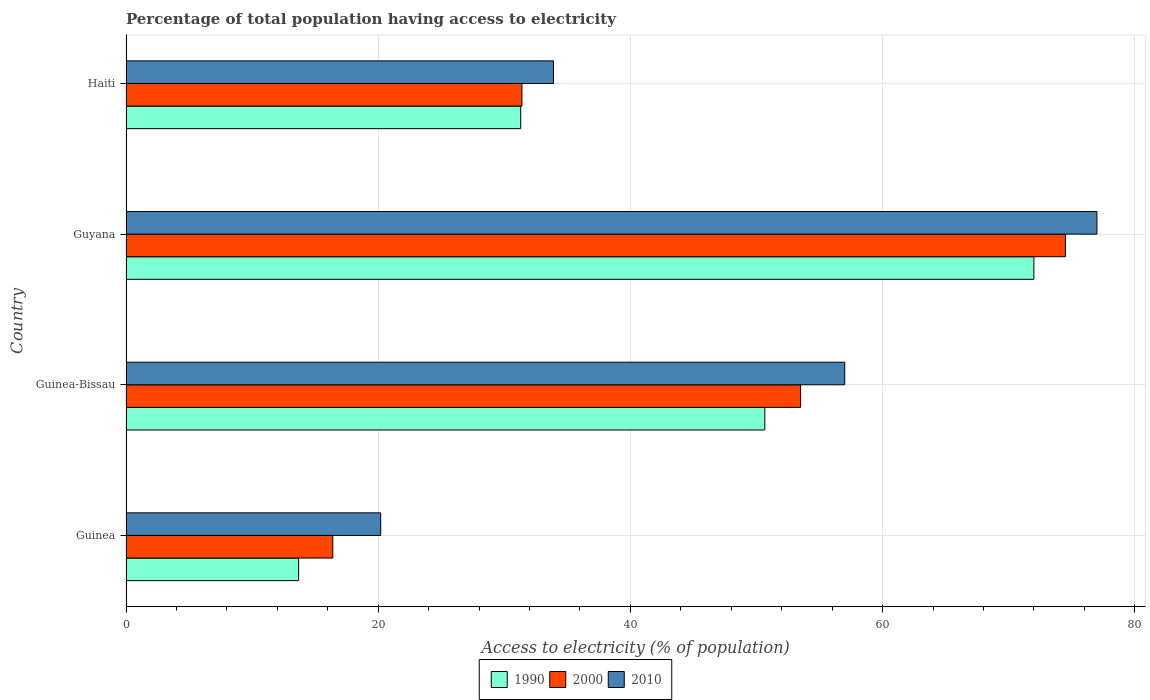How many different coloured bars are there?
Your response must be concise. 3. How many groups of bars are there?
Ensure brevity in your answer.  4. How many bars are there on the 2nd tick from the top?
Make the answer very short. 3. How many bars are there on the 1st tick from the bottom?
Offer a very short reply. 3. What is the label of the 4th group of bars from the top?
Your response must be concise. Guinea. What is the percentage of population that have access to electricity in 2000 in Guinea-Bissau?
Your answer should be very brief. 53.5. Across all countries, what is the maximum percentage of population that have access to electricity in 2000?
Your response must be concise. 74.5. Across all countries, what is the minimum percentage of population that have access to electricity in 1990?
Offer a terse response. 13.69. In which country was the percentage of population that have access to electricity in 1990 maximum?
Provide a short and direct response. Guyana. In which country was the percentage of population that have access to electricity in 2010 minimum?
Make the answer very short. Guinea. What is the total percentage of population that have access to electricity in 1990 in the graph?
Offer a very short reply. 167.65. What is the difference between the percentage of population that have access to electricity in 2000 in Guinea-Bissau and that in Haiti?
Offer a very short reply. 22.1. What is the average percentage of population that have access to electricity in 2010 per country?
Offer a terse response. 47.02. What is the difference between the percentage of population that have access to electricity in 2010 and percentage of population that have access to electricity in 1990 in Guinea?
Keep it short and to the point. 6.51. What is the ratio of the percentage of population that have access to electricity in 2010 in Guinea to that in Haiti?
Keep it short and to the point. 0.6. Is the percentage of population that have access to electricity in 2000 in Guinea less than that in Guinea-Bissau?
Ensure brevity in your answer.  Yes. What is the difference between the highest and the lowest percentage of population that have access to electricity in 2000?
Give a very brief answer. 58.1. Is the sum of the percentage of population that have access to electricity in 2010 in Guinea-Bissau and Guyana greater than the maximum percentage of population that have access to electricity in 2000 across all countries?
Offer a very short reply. Yes. What does the 1st bar from the top in Guinea represents?
Give a very brief answer. 2010. How many bars are there?
Provide a succinct answer. 12. Are all the bars in the graph horizontal?
Give a very brief answer. Yes. What is the difference between two consecutive major ticks on the X-axis?
Offer a terse response. 20. Are the values on the major ticks of X-axis written in scientific E-notation?
Your answer should be very brief. No. Does the graph contain grids?
Your response must be concise. Yes. How are the legend labels stacked?
Provide a short and direct response. Horizontal. What is the title of the graph?
Provide a succinct answer. Percentage of total population having access to electricity. Does "2006" appear as one of the legend labels in the graph?
Ensure brevity in your answer.  No. What is the label or title of the X-axis?
Your answer should be compact. Access to electricity (% of population). What is the label or title of the Y-axis?
Offer a terse response. Country. What is the Access to electricity (% of population) of 1990 in Guinea?
Your answer should be very brief. 13.69. What is the Access to electricity (% of population) in 2010 in Guinea?
Provide a short and direct response. 20.2. What is the Access to electricity (% of population) in 1990 in Guinea-Bissau?
Offer a very short reply. 50.66. What is the Access to electricity (% of population) in 2000 in Guinea-Bissau?
Make the answer very short. 53.5. What is the Access to electricity (% of population) of 2010 in Guinea-Bissau?
Provide a succinct answer. 57. What is the Access to electricity (% of population) of 2000 in Guyana?
Offer a terse response. 74.5. What is the Access to electricity (% of population) of 2010 in Guyana?
Ensure brevity in your answer.  77. What is the Access to electricity (% of population) of 1990 in Haiti?
Give a very brief answer. 31.3. What is the Access to electricity (% of population) of 2000 in Haiti?
Your answer should be very brief. 31.4. What is the Access to electricity (% of population) of 2010 in Haiti?
Keep it short and to the point. 33.9. Across all countries, what is the maximum Access to electricity (% of population) in 2000?
Provide a short and direct response. 74.5. Across all countries, what is the maximum Access to electricity (% of population) in 2010?
Ensure brevity in your answer.  77. Across all countries, what is the minimum Access to electricity (% of population) in 1990?
Ensure brevity in your answer.  13.69. Across all countries, what is the minimum Access to electricity (% of population) of 2000?
Make the answer very short. 16.4. Across all countries, what is the minimum Access to electricity (% of population) in 2010?
Your response must be concise. 20.2. What is the total Access to electricity (% of population) in 1990 in the graph?
Keep it short and to the point. 167.65. What is the total Access to electricity (% of population) in 2000 in the graph?
Your answer should be compact. 175.8. What is the total Access to electricity (% of population) in 2010 in the graph?
Give a very brief answer. 188.1. What is the difference between the Access to electricity (% of population) of 1990 in Guinea and that in Guinea-Bissau?
Offer a very short reply. -36.97. What is the difference between the Access to electricity (% of population) in 2000 in Guinea and that in Guinea-Bissau?
Ensure brevity in your answer.  -37.1. What is the difference between the Access to electricity (% of population) in 2010 in Guinea and that in Guinea-Bissau?
Provide a succinct answer. -36.8. What is the difference between the Access to electricity (% of population) of 1990 in Guinea and that in Guyana?
Offer a terse response. -58.31. What is the difference between the Access to electricity (% of population) of 2000 in Guinea and that in Guyana?
Keep it short and to the point. -58.1. What is the difference between the Access to electricity (% of population) in 2010 in Guinea and that in Guyana?
Your answer should be very brief. -56.8. What is the difference between the Access to electricity (% of population) in 1990 in Guinea and that in Haiti?
Keep it short and to the point. -17.61. What is the difference between the Access to electricity (% of population) in 2000 in Guinea and that in Haiti?
Offer a very short reply. -15. What is the difference between the Access to electricity (% of population) in 2010 in Guinea and that in Haiti?
Ensure brevity in your answer.  -13.7. What is the difference between the Access to electricity (% of population) in 1990 in Guinea-Bissau and that in Guyana?
Ensure brevity in your answer.  -21.34. What is the difference between the Access to electricity (% of population) in 1990 in Guinea-Bissau and that in Haiti?
Keep it short and to the point. 19.36. What is the difference between the Access to electricity (% of population) of 2000 in Guinea-Bissau and that in Haiti?
Your answer should be compact. 22.1. What is the difference between the Access to electricity (% of population) in 2010 in Guinea-Bissau and that in Haiti?
Your answer should be very brief. 23.1. What is the difference between the Access to electricity (% of population) in 1990 in Guyana and that in Haiti?
Your response must be concise. 40.7. What is the difference between the Access to electricity (% of population) in 2000 in Guyana and that in Haiti?
Your answer should be compact. 43.1. What is the difference between the Access to electricity (% of population) of 2010 in Guyana and that in Haiti?
Give a very brief answer. 43.1. What is the difference between the Access to electricity (% of population) of 1990 in Guinea and the Access to electricity (% of population) of 2000 in Guinea-Bissau?
Provide a short and direct response. -39.81. What is the difference between the Access to electricity (% of population) of 1990 in Guinea and the Access to electricity (% of population) of 2010 in Guinea-Bissau?
Ensure brevity in your answer.  -43.31. What is the difference between the Access to electricity (% of population) in 2000 in Guinea and the Access to electricity (% of population) in 2010 in Guinea-Bissau?
Provide a succinct answer. -40.6. What is the difference between the Access to electricity (% of population) of 1990 in Guinea and the Access to electricity (% of population) of 2000 in Guyana?
Your answer should be compact. -60.81. What is the difference between the Access to electricity (% of population) in 1990 in Guinea and the Access to electricity (% of population) in 2010 in Guyana?
Your response must be concise. -63.31. What is the difference between the Access to electricity (% of population) in 2000 in Guinea and the Access to electricity (% of population) in 2010 in Guyana?
Provide a short and direct response. -60.6. What is the difference between the Access to electricity (% of population) of 1990 in Guinea and the Access to electricity (% of population) of 2000 in Haiti?
Provide a short and direct response. -17.71. What is the difference between the Access to electricity (% of population) of 1990 in Guinea and the Access to electricity (% of population) of 2010 in Haiti?
Give a very brief answer. -20.21. What is the difference between the Access to electricity (% of population) in 2000 in Guinea and the Access to electricity (% of population) in 2010 in Haiti?
Provide a succinct answer. -17.5. What is the difference between the Access to electricity (% of population) in 1990 in Guinea-Bissau and the Access to electricity (% of population) in 2000 in Guyana?
Your answer should be very brief. -23.84. What is the difference between the Access to electricity (% of population) of 1990 in Guinea-Bissau and the Access to electricity (% of population) of 2010 in Guyana?
Make the answer very short. -26.34. What is the difference between the Access to electricity (% of population) of 2000 in Guinea-Bissau and the Access to electricity (% of population) of 2010 in Guyana?
Make the answer very short. -23.5. What is the difference between the Access to electricity (% of population) of 1990 in Guinea-Bissau and the Access to electricity (% of population) of 2000 in Haiti?
Ensure brevity in your answer.  19.26. What is the difference between the Access to electricity (% of population) in 1990 in Guinea-Bissau and the Access to electricity (% of population) in 2010 in Haiti?
Make the answer very short. 16.76. What is the difference between the Access to electricity (% of population) of 2000 in Guinea-Bissau and the Access to electricity (% of population) of 2010 in Haiti?
Your response must be concise. 19.6. What is the difference between the Access to electricity (% of population) in 1990 in Guyana and the Access to electricity (% of population) in 2000 in Haiti?
Offer a terse response. 40.6. What is the difference between the Access to electricity (% of population) of 1990 in Guyana and the Access to electricity (% of population) of 2010 in Haiti?
Keep it short and to the point. 38.1. What is the difference between the Access to electricity (% of population) of 2000 in Guyana and the Access to electricity (% of population) of 2010 in Haiti?
Ensure brevity in your answer.  40.6. What is the average Access to electricity (% of population) in 1990 per country?
Your response must be concise. 41.91. What is the average Access to electricity (% of population) of 2000 per country?
Your response must be concise. 43.95. What is the average Access to electricity (% of population) in 2010 per country?
Your response must be concise. 47.02. What is the difference between the Access to electricity (% of population) in 1990 and Access to electricity (% of population) in 2000 in Guinea?
Ensure brevity in your answer.  -2.71. What is the difference between the Access to electricity (% of population) of 1990 and Access to electricity (% of population) of 2010 in Guinea?
Ensure brevity in your answer.  -6.51. What is the difference between the Access to electricity (% of population) in 2000 and Access to electricity (% of population) in 2010 in Guinea?
Provide a succinct answer. -3.8. What is the difference between the Access to electricity (% of population) of 1990 and Access to electricity (% of population) of 2000 in Guinea-Bissau?
Ensure brevity in your answer.  -2.84. What is the difference between the Access to electricity (% of population) of 1990 and Access to electricity (% of population) of 2010 in Guinea-Bissau?
Provide a succinct answer. -6.34. What is the difference between the Access to electricity (% of population) of 1990 and Access to electricity (% of population) of 2000 in Guyana?
Your answer should be compact. -2.5. What is the difference between the Access to electricity (% of population) of 1990 and Access to electricity (% of population) of 2010 in Guyana?
Make the answer very short. -5. What is the difference between the Access to electricity (% of population) of 2000 and Access to electricity (% of population) of 2010 in Guyana?
Ensure brevity in your answer.  -2.5. What is the difference between the Access to electricity (% of population) in 1990 and Access to electricity (% of population) in 2010 in Haiti?
Your answer should be compact. -2.6. What is the difference between the Access to electricity (% of population) of 2000 and Access to electricity (% of population) of 2010 in Haiti?
Keep it short and to the point. -2.5. What is the ratio of the Access to electricity (% of population) in 1990 in Guinea to that in Guinea-Bissau?
Offer a very short reply. 0.27. What is the ratio of the Access to electricity (% of population) in 2000 in Guinea to that in Guinea-Bissau?
Your answer should be compact. 0.31. What is the ratio of the Access to electricity (% of population) of 2010 in Guinea to that in Guinea-Bissau?
Give a very brief answer. 0.35. What is the ratio of the Access to electricity (% of population) in 1990 in Guinea to that in Guyana?
Keep it short and to the point. 0.19. What is the ratio of the Access to electricity (% of population) of 2000 in Guinea to that in Guyana?
Make the answer very short. 0.22. What is the ratio of the Access to electricity (% of population) in 2010 in Guinea to that in Guyana?
Your answer should be very brief. 0.26. What is the ratio of the Access to electricity (% of population) in 1990 in Guinea to that in Haiti?
Give a very brief answer. 0.44. What is the ratio of the Access to electricity (% of population) of 2000 in Guinea to that in Haiti?
Provide a short and direct response. 0.52. What is the ratio of the Access to electricity (% of population) in 2010 in Guinea to that in Haiti?
Your response must be concise. 0.6. What is the ratio of the Access to electricity (% of population) in 1990 in Guinea-Bissau to that in Guyana?
Your response must be concise. 0.7. What is the ratio of the Access to electricity (% of population) in 2000 in Guinea-Bissau to that in Guyana?
Provide a succinct answer. 0.72. What is the ratio of the Access to electricity (% of population) of 2010 in Guinea-Bissau to that in Guyana?
Your response must be concise. 0.74. What is the ratio of the Access to electricity (% of population) of 1990 in Guinea-Bissau to that in Haiti?
Provide a short and direct response. 1.62. What is the ratio of the Access to electricity (% of population) in 2000 in Guinea-Bissau to that in Haiti?
Make the answer very short. 1.7. What is the ratio of the Access to electricity (% of population) of 2010 in Guinea-Bissau to that in Haiti?
Your answer should be compact. 1.68. What is the ratio of the Access to electricity (% of population) in 1990 in Guyana to that in Haiti?
Offer a very short reply. 2.3. What is the ratio of the Access to electricity (% of population) in 2000 in Guyana to that in Haiti?
Ensure brevity in your answer.  2.37. What is the ratio of the Access to electricity (% of population) of 2010 in Guyana to that in Haiti?
Your response must be concise. 2.27. What is the difference between the highest and the second highest Access to electricity (% of population) of 1990?
Give a very brief answer. 21.34. What is the difference between the highest and the second highest Access to electricity (% of population) in 2000?
Your response must be concise. 21. What is the difference between the highest and the second highest Access to electricity (% of population) in 2010?
Ensure brevity in your answer.  20. What is the difference between the highest and the lowest Access to electricity (% of population) in 1990?
Make the answer very short. 58.31. What is the difference between the highest and the lowest Access to electricity (% of population) in 2000?
Your answer should be very brief. 58.1. What is the difference between the highest and the lowest Access to electricity (% of population) in 2010?
Offer a terse response. 56.8. 